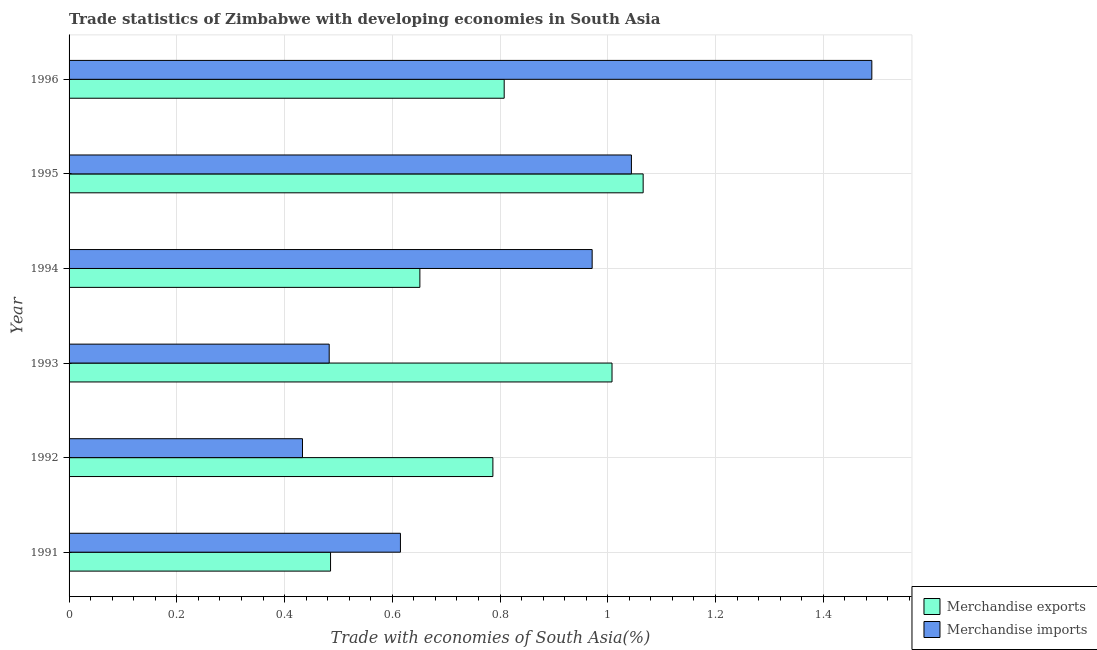Are the number of bars per tick equal to the number of legend labels?
Your answer should be compact. Yes. How many bars are there on the 5th tick from the top?
Ensure brevity in your answer.  2. How many bars are there on the 4th tick from the bottom?
Ensure brevity in your answer.  2. In how many cases, is the number of bars for a given year not equal to the number of legend labels?
Offer a terse response. 0. What is the merchandise exports in 1991?
Provide a short and direct response. 0.49. Across all years, what is the maximum merchandise exports?
Provide a succinct answer. 1.07. Across all years, what is the minimum merchandise imports?
Provide a short and direct response. 0.43. In which year was the merchandise exports minimum?
Your answer should be very brief. 1991. What is the total merchandise imports in the graph?
Offer a terse response. 5.04. What is the difference between the merchandise exports in 1993 and that in 1995?
Your answer should be compact. -0.06. What is the difference between the merchandise imports in 1992 and the merchandise exports in 1995?
Give a very brief answer. -0.63. What is the average merchandise imports per year?
Your response must be concise. 0.84. In the year 1996, what is the difference between the merchandise exports and merchandise imports?
Your answer should be compact. -0.68. In how many years, is the merchandise imports greater than 0.8 %?
Your answer should be very brief. 3. What is the ratio of the merchandise imports in 1991 to that in 1995?
Make the answer very short. 0.59. Is the merchandise exports in 1994 less than that in 1995?
Provide a short and direct response. Yes. What is the difference between the highest and the second highest merchandise imports?
Offer a terse response. 0.45. What is the difference between the highest and the lowest merchandise imports?
Provide a short and direct response. 1.06. In how many years, is the merchandise imports greater than the average merchandise imports taken over all years?
Your response must be concise. 3. Is the sum of the merchandise exports in 1995 and 1996 greater than the maximum merchandise imports across all years?
Offer a terse response. Yes. What does the 2nd bar from the top in 1992 represents?
Your response must be concise. Merchandise exports. How many bars are there?
Ensure brevity in your answer.  12. Are all the bars in the graph horizontal?
Offer a terse response. Yes. What is the difference between two consecutive major ticks on the X-axis?
Offer a terse response. 0.2. Are the values on the major ticks of X-axis written in scientific E-notation?
Provide a short and direct response. No. Does the graph contain any zero values?
Provide a succinct answer. No. Does the graph contain grids?
Provide a short and direct response. Yes. How many legend labels are there?
Your answer should be very brief. 2. What is the title of the graph?
Provide a succinct answer. Trade statistics of Zimbabwe with developing economies in South Asia. Does "Malaria" appear as one of the legend labels in the graph?
Make the answer very short. No. What is the label or title of the X-axis?
Your response must be concise. Trade with economies of South Asia(%). What is the label or title of the Y-axis?
Offer a very short reply. Year. What is the Trade with economies of South Asia(%) of Merchandise exports in 1991?
Provide a short and direct response. 0.49. What is the Trade with economies of South Asia(%) in Merchandise imports in 1991?
Offer a very short reply. 0.62. What is the Trade with economies of South Asia(%) of Merchandise exports in 1992?
Keep it short and to the point. 0.79. What is the Trade with economies of South Asia(%) of Merchandise imports in 1992?
Provide a short and direct response. 0.43. What is the Trade with economies of South Asia(%) in Merchandise exports in 1993?
Your response must be concise. 1.01. What is the Trade with economies of South Asia(%) in Merchandise imports in 1993?
Your response must be concise. 0.48. What is the Trade with economies of South Asia(%) in Merchandise exports in 1994?
Give a very brief answer. 0.65. What is the Trade with economies of South Asia(%) in Merchandise imports in 1994?
Your response must be concise. 0.97. What is the Trade with economies of South Asia(%) in Merchandise exports in 1995?
Offer a very short reply. 1.07. What is the Trade with economies of South Asia(%) of Merchandise imports in 1995?
Your answer should be compact. 1.04. What is the Trade with economies of South Asia(%) of Merchandise exports in 1996?
Give a very brief answer. 0.81. What is the Trade with economies of South Asia(%) of Merchandise imports in 1996?
Make the answer very short. 1.49. Across all years, what is the maximum Trade with economies of South Asia(%) in Merchandise exports?
Your answer should be very brief. 1.07. Across all years, what is the maximum Trade with economies of South Asia(%) of Merchandise imports?
Provide a succinct answer. 1.49. Across all years, what is the minimum Trade with economies of South Asia(%) in Merchandise exports?
Your response must be concise. 0.49. Across all years, what is the minimum Trade with economies of South Asia(%) in Merchandise imports?
Offer a very short reply. 0.43. What is the total Trade with economies of South Asia(%) of Merchandise exports in the graph?
Provide a succinct answer. 4.8. What is the total Trade with economies of South Asia(%) in Merchandise imports in the graph?
Make the answer very short. 5.04. What is the difference between the Trade with economies of South Asia(%) of Merchandise exports in 1991 and that in 1992?
Offer a terse response. -0.3. What is the difference between the Trade with economies of South Asia(%) of Merchandise imports in 1991 and that in 1992?
Offer a terse response. 0.18. What is the difference between the Trade with economies of South Asia(%) of Merchandise exports in 1991 and that in 1993?
Keep it short and to the point. -0.52. What is the difference between the Trade with economies of South Asia(%) of Merchandise imports in 1991 and that in 1993?
Provide a succinct answer. 0.13. What is the difference between the Trade with economies of South Asia(%) in Merchandise exports in 1991 and that in 1994?
Your answer should be very brief. -0.17. What is the difference between the Trade with economies of South Asia(%) of Merchandise imports in 1991 and that in 1994?
Your response must be concise. -0.36. What is the difference between the Trade with economies of South Asia(%) in Merchandise exports in 1991 and that in 1995?
Offer a very short reply. -0.58. What is the difference between the Trade with economies of South Asia(%) of Merchandise imports in 1991 and that in 1995?
Your response must be concise. -0.43. What is the difference between the Trade with economies of South Asia(%) in Merchandise exports in 1991 and that in 1996?
Offer a terse response. -0.32. What is the difference between the Trade with economies of South Asia(%) in Merchandise imports in 1991 and that in 1996?
Keep it short and to the point. -0.88. What is the difference between the Trade with economies of South Asia(%) of Merchandise exports in 1992 and that in 1993?
Provide a short and direct response. -0.22. What is the difference between the Trade with economies of South Asia(%) in Merchandise imports in 1992 and that in 1993?
Give a very brief answer. -0.05. What is the difference between the Trade with economies of South Asia(%) of Merchandise exports in 1992 and that in 1994?
Make the answer very short. 0.14. What is the difference between the Trade with economies of South Asia(%) of Merchandise imports in 1992 and that in 1994?
Keep it short and to the point. -0.54. What is the difference between the Trade with economies of South Asia(%) of Merchandise exports in 1992 and that in 1995?
Your answer should be compact. -0.28. What is the difference between the Trade with economies of South Asia(%) in Merchandise imports in 1992 and that in 1995?
Offer a very short reply. -0.61. What is the difference between the Trade with economies of South Asia(%) of Merchandise exports in 1992 and that in 1996?
Offer a very short reply. -0.02. What is the difference between the Trade with economies of South Asia(%) of Merchandise imports in 1992 and that in 1996?
Your answer should be compact. -1.06. What is the difference between the Trade with economies of South Asia(%) in Merchandise exports in 1993 and that in 1994?
Your answer should be compact. 0.36. What is the difference between the Trade with economies of South Asia(%) in Merchandise imports in 1993 and that in 1994?
Offer a very short reply. -0.49. What is the difference between the Trade with economies of South Asia(%) in Merchandise exports in 1993 and that in 1995?
Your answer should be compact. -0.06. What is the difference between the Trade with economies of South Asia(%) in Merchandise imports in 1993 and that in 1995?
Offer a terse response. -0.56. What is the difference between the Trade with economies of South Asia(%) of Merchandise exports in 1993 and that in 1996?
Ensure brevity in your answer.  0.2. What is the difference between the Trade with economies of South Asia(%) in Merchandise imports in 1993 and that in 1996?
Your answer should be very brief. -1.01. What is the difference between the Trade with economies of South Asia(%) of Merchandise exports in 1994 and that in 1995?
Provide a succinct answer. -0.41. What is the difference between the Trade with economies of South Asia(%) in Merchandise imports in 1994 and that in 1995?
Give a very brief answer. -0.07. What is the difference between the Trade with economies of South Asia(%) in Merchandise exports in 1994 and that in 1996?
Give a very brief answer. -0.16. What is the difference between the Trade with economies of South Asia(%) in Merchandise imports in 1994 and that in 1996?
Provide a short and direct response. -0.52. What is the difference between the Trade with economies of South Asia(%) of Merchandise exports in 1995 and that in 1996?
Make the answer very short. 0.26. What is the difference between the Trade with economies of South Asia(%) of Merchandise imports in 1995 and that in 1996?
Your answer should be very brief. -0.45. What is the difference between the Trade with economies of South Asia(%) in Merchandise exports in 1991 and the Trade with economies of South Asia(%) in Merchandise imports in 1992?
Give a very brief answer. 0.05. What is the difference between the Trade with economies of South Asia(%) in Merchandise exports in 1991 and the Trade with economies of South Asia(%) in Merchandise imports in 1993?
Ensure brevity in your answer.  0. What is the difference between the Trade with economies of South Asia(%) in Merchandise exports in 1991 and the Trade with economies of South Asia(%) in Merchandise imports in 1994?
Provide a succinct answer. -0.49. What is the difference between the Trade with economies of South Asia(%) in Merchandise exports in 1991 and the Trade with economies of South Asia(%) in Merchandise imports in 1995?
Your answer should be compact. -0.56. What is the difference between the Trade with economies of South Asia(%) of Merchandise exports in 1991 and the Trade with economies of South Asia(%) of Merchandise imports in 1996?
Provide a short and direct response. -1. What is the difference between the Trade with economies of South Asia(%) of Merchandise exports in 1992 and the Trade with economies of South Asia(%) of Merchandise imports in 1993?
Make the answer very short. 0.3. What is the difference between the Trade with economies of South Asia(%) in Merchandise exports in 1992 and the Trade with economies of South Asia(%) in Merchandise imports in 1994?
Your response must be concise. -0.18. What is the difference between the Trade with economies of South Asia(%) of Merchandise exports in 1992 and the Trade with economies of South Asia(%) of Merchandise imports in 1995?
Give a very brief answer. -0.26. What is the difference between the Trade with economies of South Asia(%) of Merchandise exports in 1992 and the Trade with economies of South Asia(%) of Merchandise imports in 1996?
Give a very brief answer. -0.7. What is the difference between the Trade with economies of South Asia(%) in Merchandise exports in 1993 and the Trade with economies of South Asia(%) in Merchandise imports in 1994?
Offer a terse response. 0.04. What is the difference between the Trade with economies of South Asia(%) of Merchandise exports in 1993 and the Trade with economies of South Asia(%) of Merchandise imports in 1995?
Your response must be concise. -0.04. What is the difference between the Trade with economies of South Asia(%) in Merchandise exports in 1993 and the Trade with economies of South Asia(%) in Merchandise imports in 1996?
Your answer should be compact. -0.48. What is the difference between the Trade with economies of South Asia(%) of Merchandise exports in 1994 and the Trade with economies of South Asia(%) of Merchandise imports in 1995?
Your response must be concise. -0.39. What is the difference between the Trade with economies of South Asia(%) of Merchandise exports in 1994 and the Trade with economies of South Asia(%) of Merchandise imports in 1996?
Provide a short and direct response. -0.84. What is the difference between the Trade with economies of South Asia(%) of Merchandise exports in 1995 and the Trade with economies of South Asia(%) of Merchandise imports in 1996?
Offer a very short reply. -0.42. What is the average Trade with economies of South Asia(%) in Merchandise exports per year?
Give a very brief answer. 0.8. What is the average Trade with economies of South Asia(%) in Merchandise imports per year?
Make the answer very short. 0.84. In the year 1991, what is the difference between the Trade with economies of South Asia(%) of Merchandise exports and Trade with economies of South Asia(%) of Merchandise imports?
Give a very brief answer. -0.13. In the year 1992, what is the difference between the Trade with economies of South Asia(%) in Merchandise exports and Trade with economies of South Asia(%) in Merchandise imports?
Provide a short and direct response. 0.35. In the year 1993, what is the difference between the Trade with economies of South Asia(%) in Merchandise exports and Trade with economies of South Asia(%) in Merchandise imports?
Your answer should be compact. 0.53. In the year 1994, what is the difference between the Trade with economies of South Asia(%) of Merchandise exports and Trade with economies of South Asia(%) of Merchandise imports?
Provide a succinct answer. -0.32. In the year 1995, what is the difference between the Trade with economies of South Asia(%) of Merchandise exports and Trade with economies of South Asia(%) of Merchandise imports?
Give a very brief answer. 0.02. In the year 1996, what is the difference between the Trade with economies of South Asia(%) in Merchandise exports and Trade with economies of South Asia(%) in Merchandise imports?
Your response must be concise. -0.68. What is the ratio of the Trade with economies of South Asia(%) of Merchandise exports in 1991 to that in 1992?
Offer a terse response. 0.62. What is the ratio of the Trade with economies of South Asia(%) in Merchandise imports in 1991 to that in 1992?
Provide a succinct answer. 1.42. What is the ratio of the Trade with economies of South Asia(%) of Merchandise exports in 1991 to that in 1993?
Your response must be concise. 0.48. What is the ratio of the Trade with economies of South Asia(%) in Merchandise imports in 1991 to that in 1993?
Provide a succinct answer. 1.27. What is the ratio of the Trade with economies of South Asia(%) of Merchandise exports in 1991 to that in 1994?
Provide a succinct answer. 0.75. What is the ratio of the Trade with economies of South Asia(%) of Merchandise imports in 1991 to that in 1994?
Give a very brief answer. 0.63. What is the ratio of the Trade with economies of South Asia(%) in Merchandise exports in 1991 to that in 1995?
Offer a very short reply. 0.46. What is the ratio of the Trade with economies of South Asia(%) of Merchandise imports in 1991 to that in 1995?
Offer a very short reply. 0.59. What is the ratio of the Trade with economies of South Asia(%) of Merchandise exports in 1991 to that in 1996?
Provide a succinct answer. 0.6. What is the ratio of the Trade with economies of South Asia(%) of Merchandise imports in 1991 to that in 1996?
Give a very brief answer. 0.41. What is the ratio of the Trade with economies of South Asia(%) of Merchandise exports in 1992 to that in 1993?
Your answer should be compact. 0.78. What is the ratio of the Trade with economies of South Asia(%) of Merchandise imports in 1992 to that in 1993?
Make the answer very short. 0.9. What is the ratio of the Trade with economies of South Asia(%) in Merchandise exports in 1992 to that in 1994?
Offer a terse response. 1.21. What is the ratio of the Trade with economies of South Asia(%) of Merchandise imports in 1992 to that in 1994?
Your response must be concise. 0.45. What is the ratio of the Trade with economies of South Asia(%) in Merchandise exports in 1992 to that in 1995?
Your answer should be very brief. 0.74. What is the ratio of the Trade with economies of South Asia(%) in Merchandise imports in 1992 to that in 1995?
Provide a succinct answer. 0.42. What is the ratio of the Trade with economies of South Asia(%) in Merchandise exports in 1992 to that in 1996?
Your response must be concise. 0.97. What is the ratio of the Trade with economies of South Asia(%) of Merchandise imports in 1992 to that in 1996?
Keep it short and to the point. 0.29. What is the ratio of the Trade with economies of South Asia(%) in Merchandise exports in 1993 to that in 1994?
Provide a short and direct response. 1.55. What is the ratio of the Trade with economies of South Asia(%) in Merchandise imports in 1993 to that in 1994?
Your response must be concise. 0.5. What is the ratio of the Trade with economies of South Asia(%) in Merchandise exports in 1993 to that in 1995?
Offer a terse response. 0.95. What is the ratio of the Trade with economies of South Asia(%) of Merchandise imports in 1993 to that in 1995?
Provide a short and direct response. 0.46. What is the ratio of the Trade with economies of South Asia(%) of Merchandise exports in 1993 to that in 1996?
Provide a succinct answer. 1.25. What is the ratio of the Trade with economies of South Asia(%) in Merchandise imports in 1993 to that in 1996?
Make the answer very short. 0.32. What is the ratio of the Trade with economies of South Asia(%) of Merchandise exports in 1994 to that in 1995?
Ensure brevity in your answer.  0.61. What is the ratio of the Trade with economies of South Asia(%) of Merchandise imports in 1994 to that in 1995?
Offer a very short reply. 0.93. What is the ratio of the Trade with economies of South Asia(%) of Merchandise exports in 1994 to that in 1996?
Your answer should be very brief. 0.81. What is the ratio of the Trade with economies of South Asia(%) of Merchandise imports in 1994 to that in 1996?
Make the answer very short. 0.65. What is the ratio of the Trade with economies of South Asia(%) in Merchandise exports in 1995 to that in 1996?
Your answer should be compact. 1.32. What is the ratio of the Trade with economies of South Asia(%) in Merchandise imports in 1995 to that in 1996?
Your answer should be very brief. 0.7. What is the difference between the highest and the second highest Trade with economies of South Asia(%) in Merchandise exports?
Ensure brevity in your answer.  0.06. What is the difference between the highest and the second highest Trade with economies of South Asia(%) of Merchandise imports?
Make the answer very short. 0.45. What is the difference between the highest and the lowest Trade with economies of South Asia(%) in Merchandise exports?
Provide a succinct answer. 0.58. What is the difference between the highest and the lowest Trade with economies of South Asia(%) of Merchandise imports?
Your answer should be compact. 1.06. 